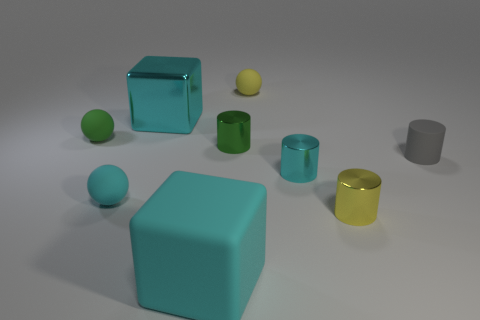Add 1 metal cylinders. How many objects exist? 10 Subtract all brown cylinders. Subtract all green balls. How many cylinders are left? 4 Subtract all spheres. How many objects are left? 6 Add 3 small cylinders. How many small cylinders are left? 7 Add 2 large shiny objects. How many large shiny objects exist? 3 Subtract 0 gray cubes. How many objects are left? 9 Subtract all big blocks. Subtract all yellow metallic cylinders. How many objects are left? 6 